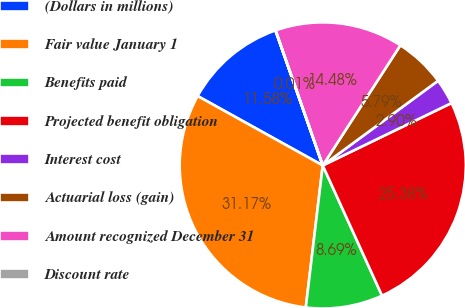Convert chart. <chart><loc_0><loc_0><loc_500><loc_500><pie_chart><fcel>(Dollars in millions)<fcel>Fair value January 1<fcel>Benefits paid<fcel>Projected benefit obligation<fcel>Interest cost<fcel>Actuarial loss (gain)<fcel>Amount recognized December 31<fcel>Discount rate<nl><fcel>11.58%<fcel>31.17%<fcel>8.69%<fcel>25.38%<fcel>2.9%<fcel>5.79%<fcel>14.48%<fcel>0.01%<nl></chart> 